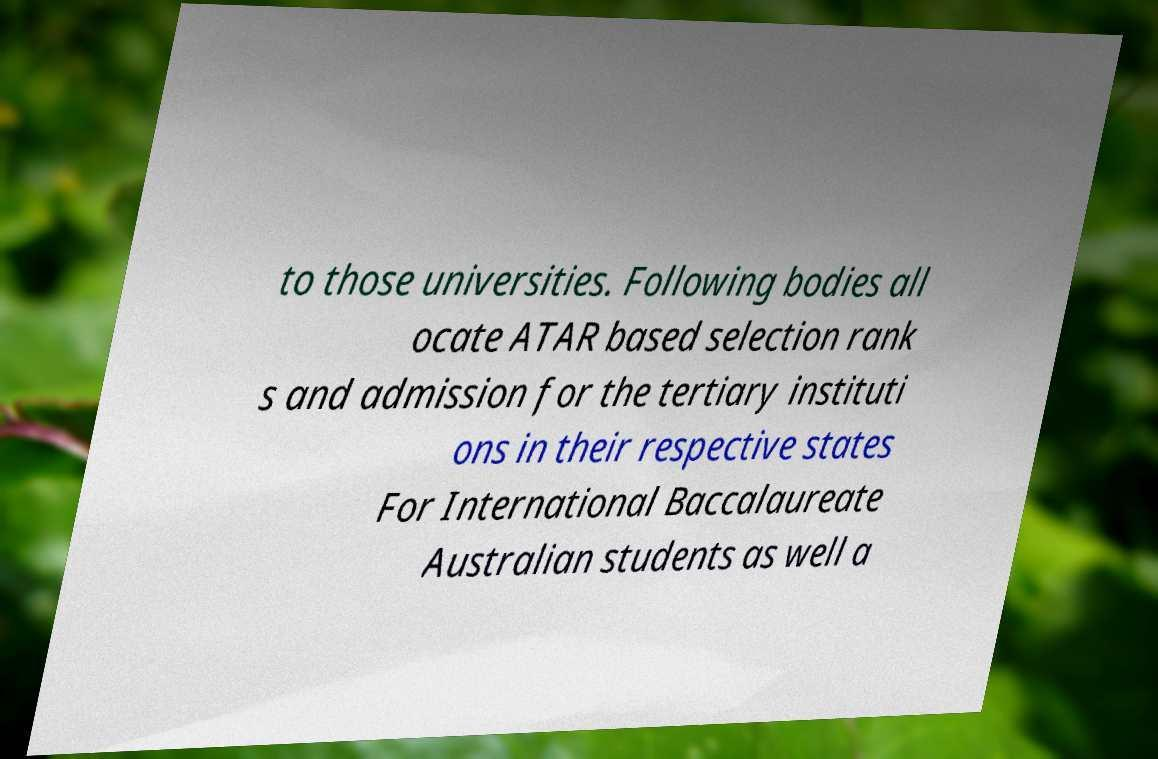For documentation purposes, I need the text within this image transcribed. Could you provide that? to those universities. Following bodies all ocate ATAR based selection rank s and admission for the tertiary instituti ons in their respective states For International Baccalaureate Australian students as well a 